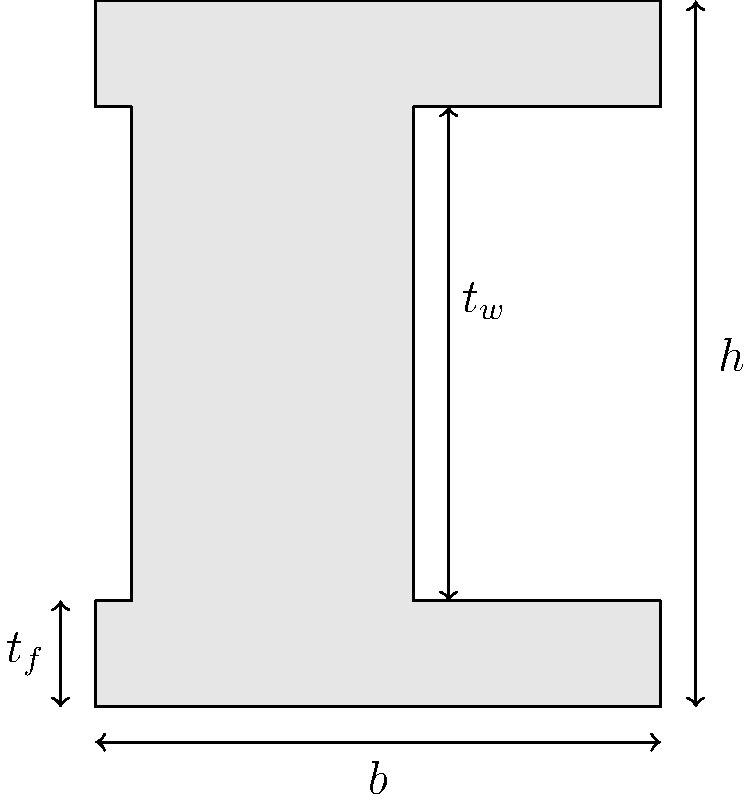As a cost-conscious civil engineer, you're tasked with determining the cross-sectional area of an I-beam for a project. The I-beam has the following dimensions: total height $h = 10$ inches, flange width $b = 8$ inches, web thickness $t_w = 1$ inch, and flange thickness $t_f = 1.5$ inches. Calculate the cross-sectional area of this I-beam. To calculate the cross-sectional area of the I-beam, we need to break it down into three rectangular components:

1. Top flange: 
   Area = $b \times t_f = 8 \times 1.5 = 12$ sq inches

2. Bottom flange:
   Area = $b \times t_f = 8 \times 1.5 = 12$ sq inches

3. Web:
   Height of web = $h - 2t_f = 10 - (2 \times 1.5) = 7$ inches
   Area = $t_w \times (h - 2t_f) = 1 \times 7 = 7$ sq inches

Total cross-sectional area:
$A_{total} = A_{top flange} + A_{bottom flange} + A_{web}$
$A_{total} = 12 + 12 + 7 = 31$ sq inches

Therefore, the cross-sectional area of the I-beam is 31 square inches.
Answer: 31 sq inches 